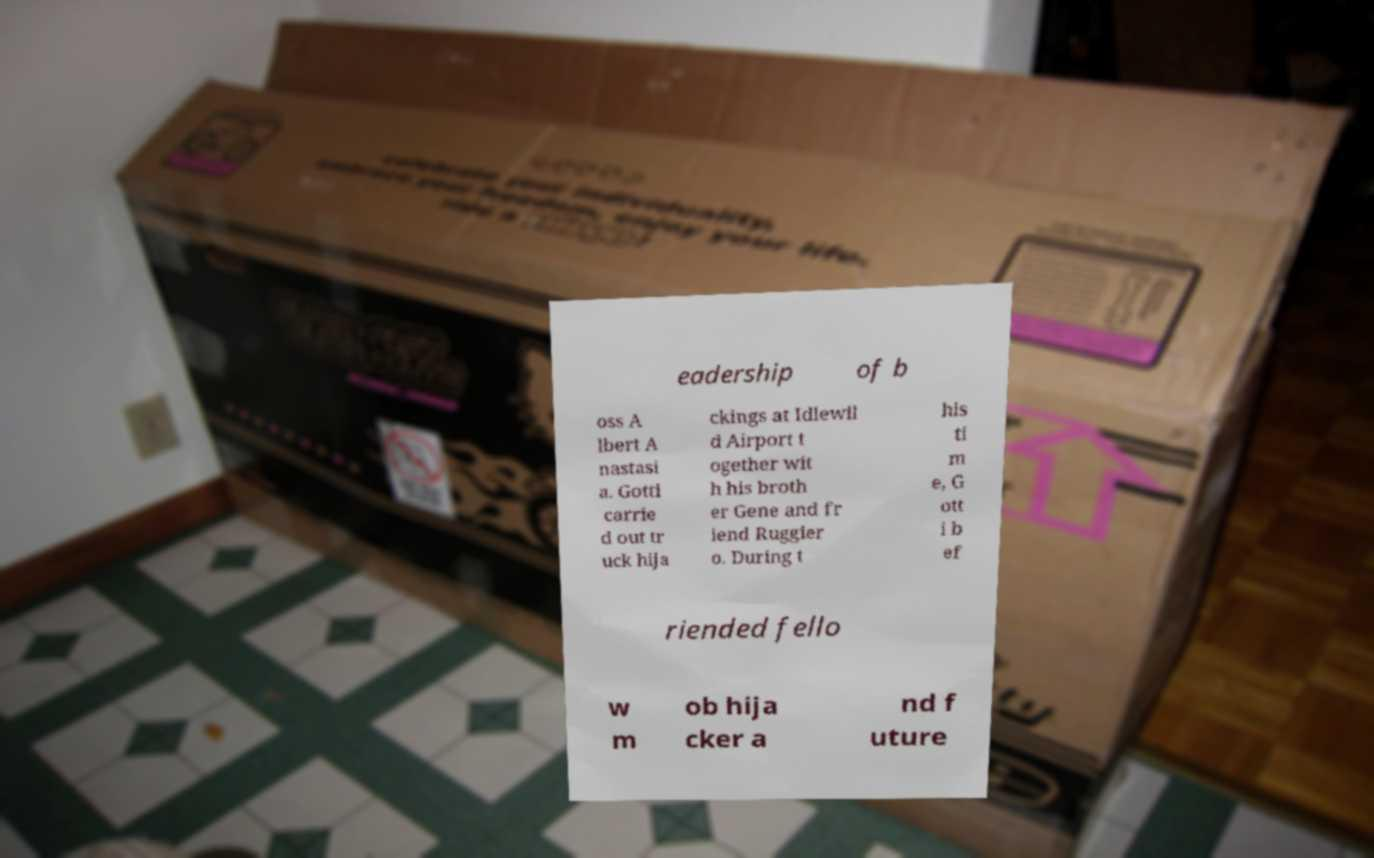I need the written content from this picture converted into text. Can you do that? eadership of b oss A lbert A nastasi a. Gotti carrie d out tr uck hija ckings at Idlewil d Airport t ogether wit h his broth er Gene and fr iend Ruggier o. During t his ti m e, G ott i b ef riended fello w m ob hija cker a nd f uture 